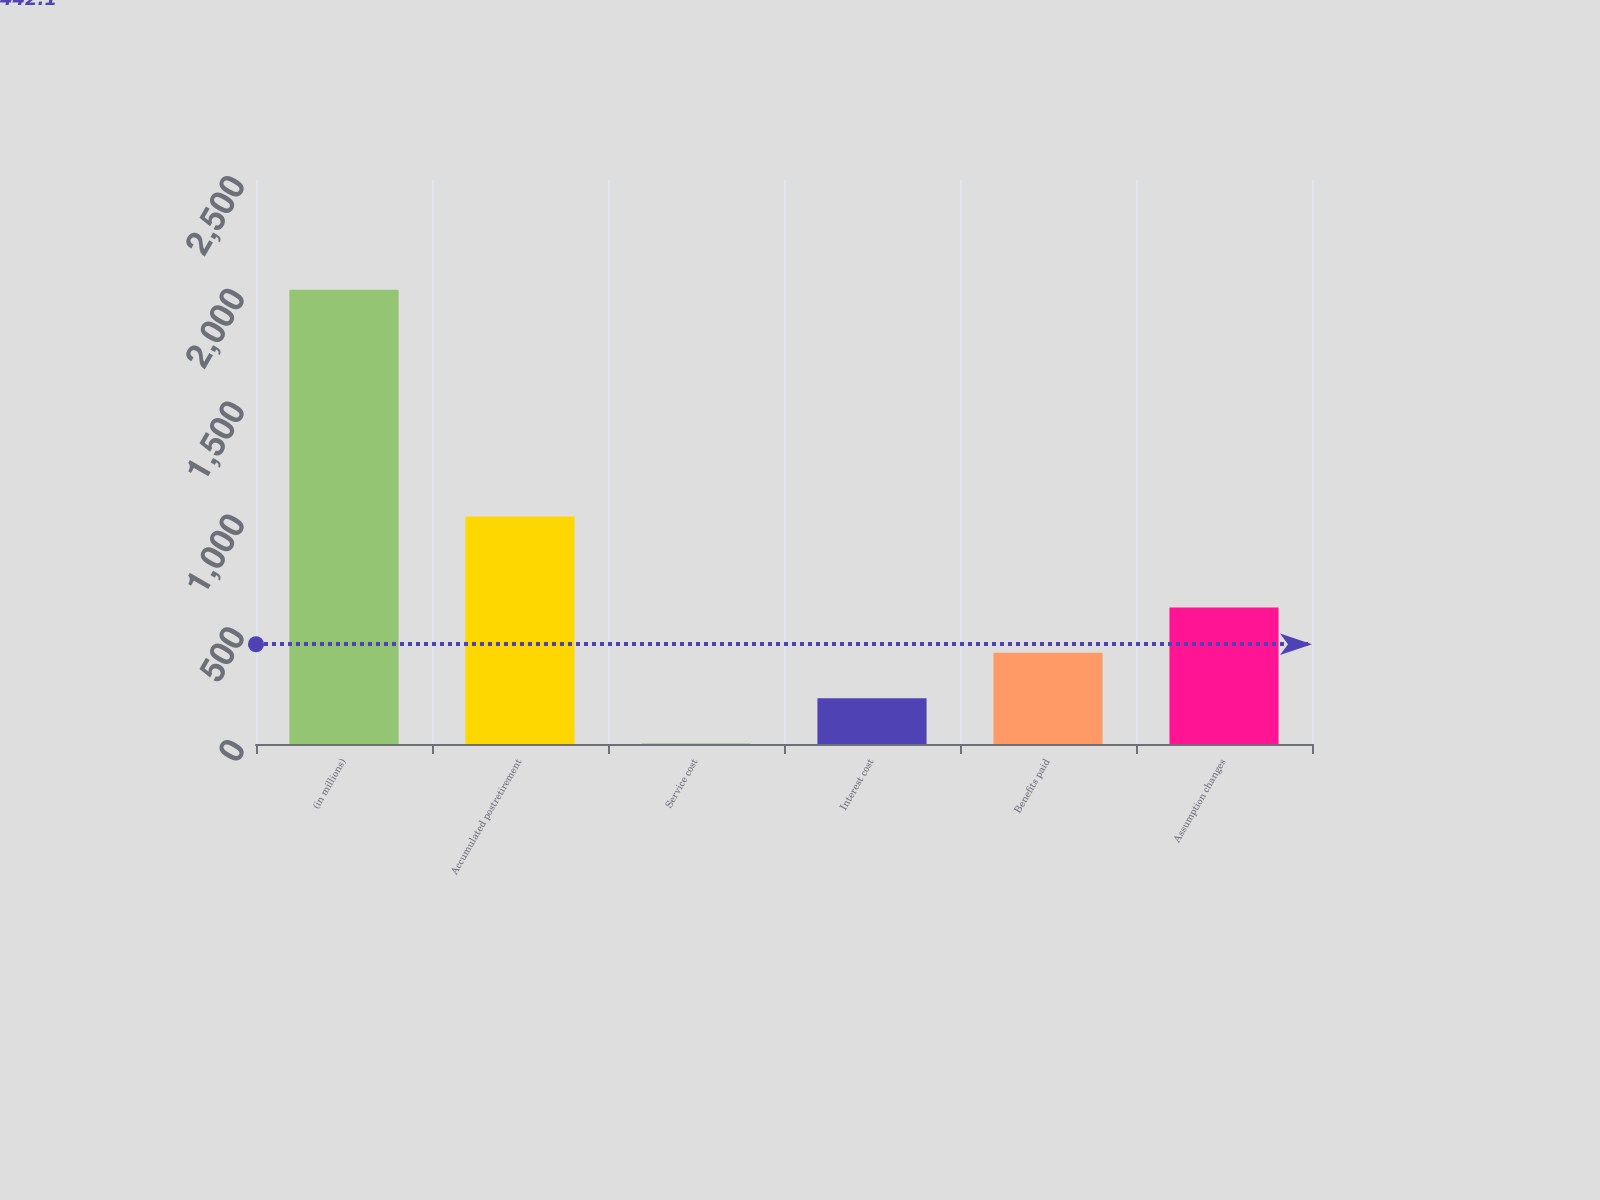Convert chart. <chart><loc_0><loc_0><loc_500><loc_500><bar_chart><fcel>(in millions)<fcel>Accumulated postretirement<fcel>Service cost<fcel>Interest cost<fcel>Benefits paid<fcel>Assumption changes<nl><fcel>2014<fcel>1008<fcel>2<fcel>203.2<fcel>404.4<fcel>605.6<nl></chart> 